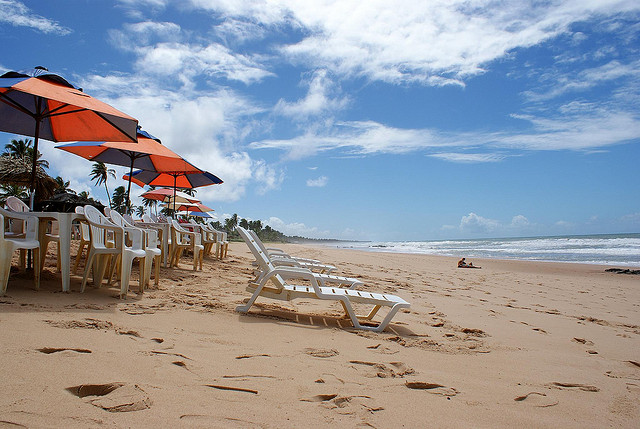Can you tell what the weather is like? The weather appears to be sunny with clear skies, which is indicated by the bright sunlight, the clear blue sky, and the absence of any visible rain clouds. 